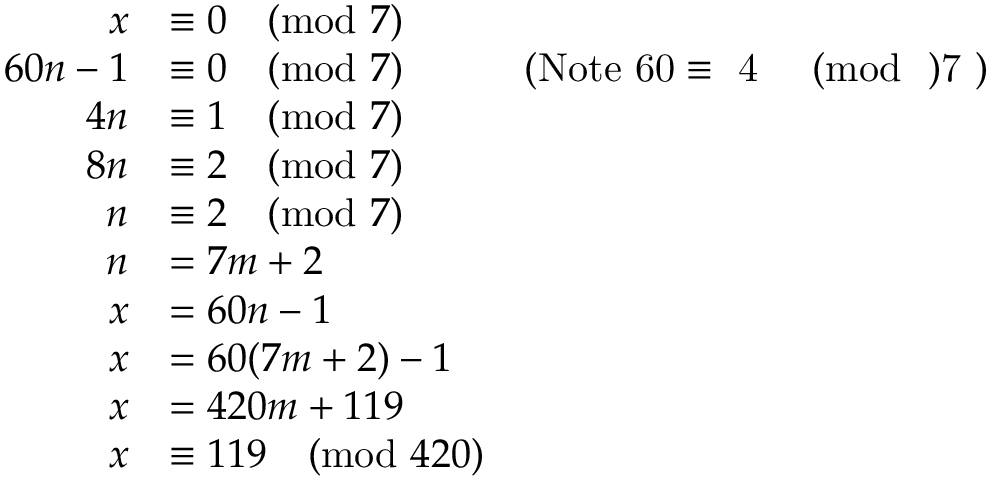Convert formula to latex. <formula><loc_0><loc_0><loc_500><loc_500>\begin{array} { r l r } { x } & { \equiv 0 \pmod { 7 } } \\ { 6 0 n - 1 } & { \equiv 0 \pmod { 7 } } & { ( N o t e 6 0 \equiv 4 \pmod { 7 } ) } \\ { 4 n } & { \equiv 1 \pmod { 7 } } \\ { 8 n } & { \equiv 2 \pmod { 7 } } \\ { n } & { \equiv 2 \pmod { 7 } } \\ { n } & { = 7 m + 2 } \\ { x } & { = 6 0 n - 1 } \\ { x } & { = 6 0 ( 7 m + 2 ) - 1 } \\ { x } & { = 4 2 0 m + 1 1 9 } \\ { x } & { \equiv 1 1 9 \pmod { 4 2 0 } } \end{array}</formula> 